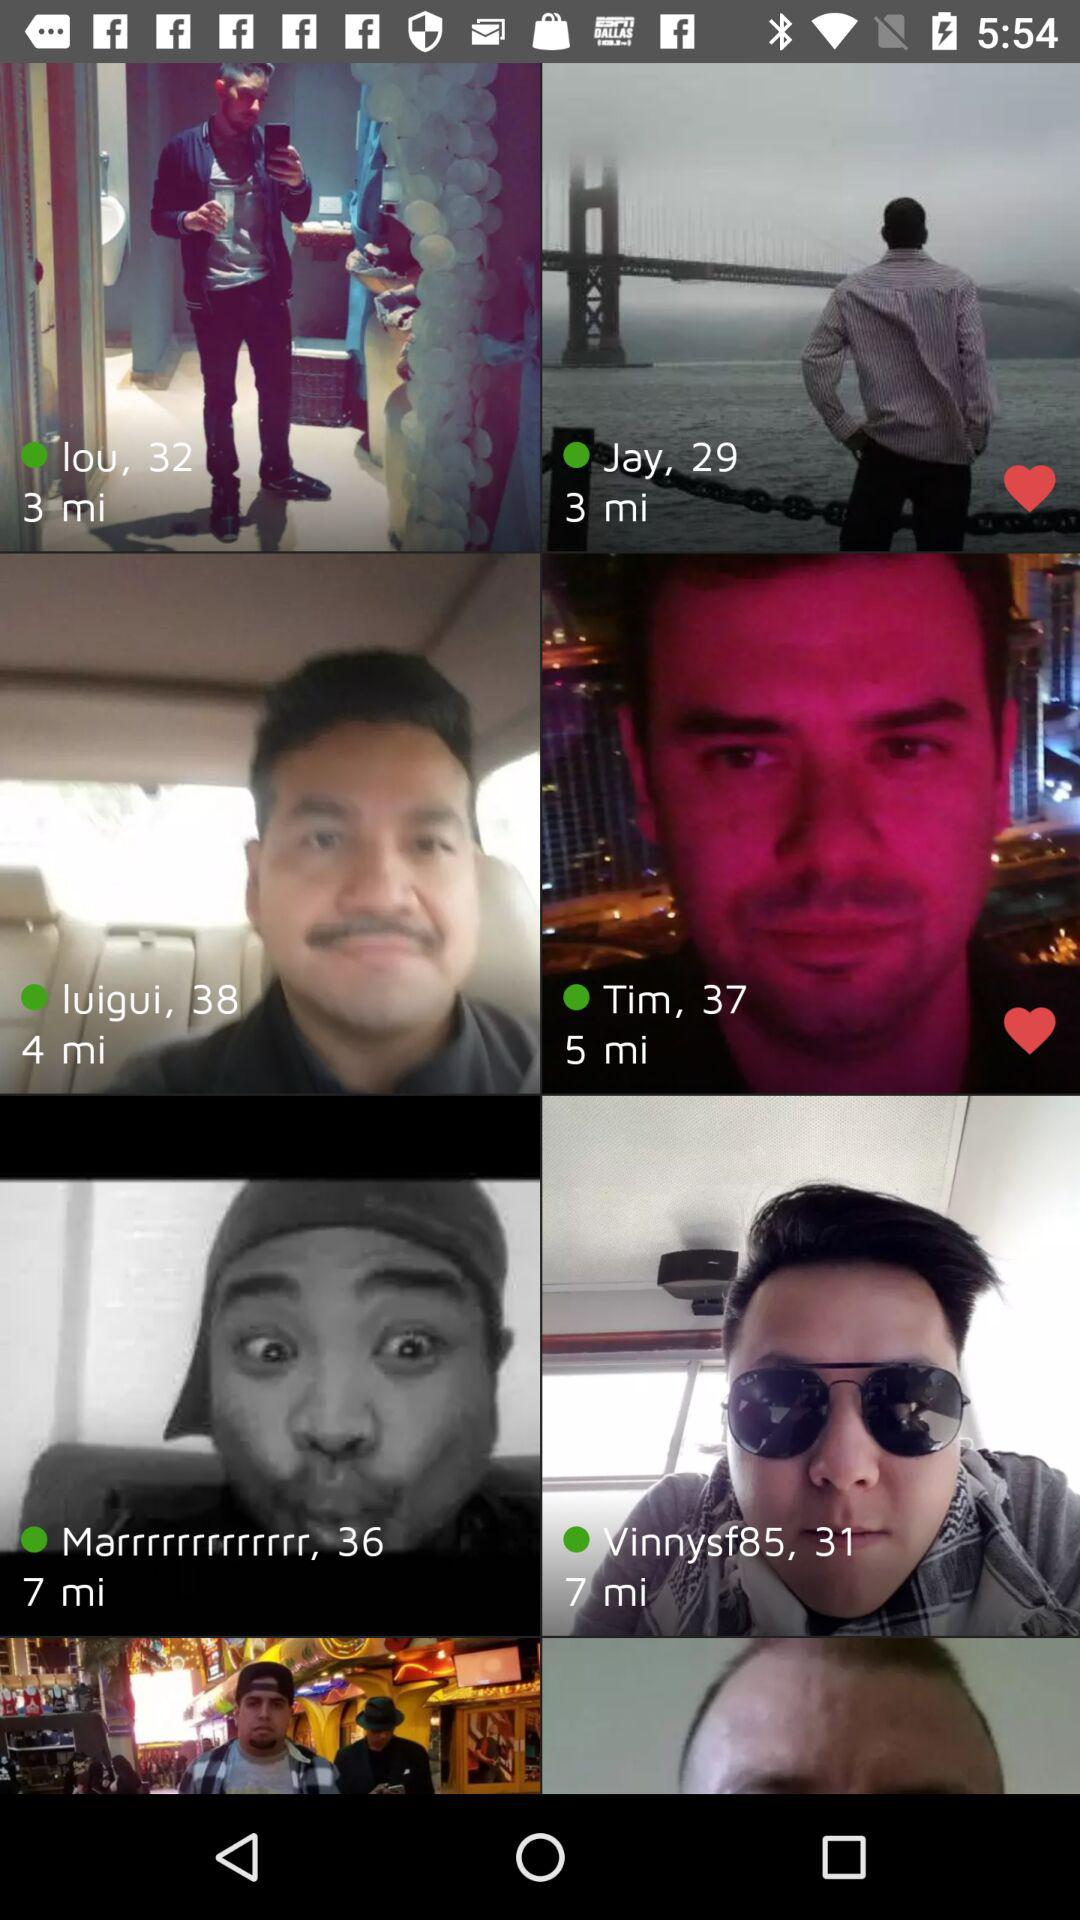What time was Tim active on the application? Tim was active on the application 5 minutes ago. 